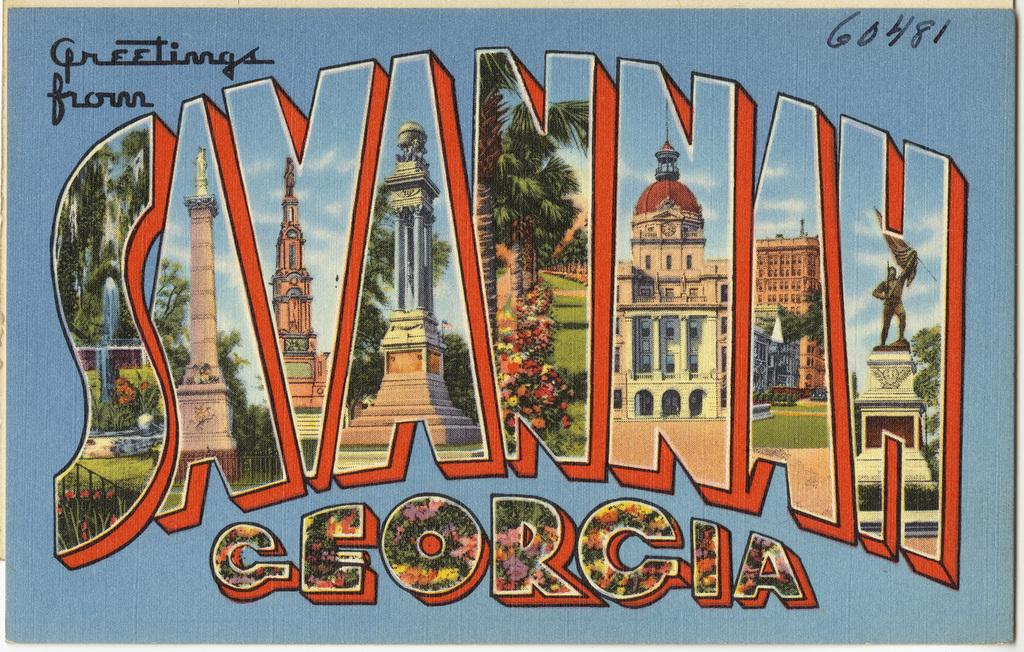Provide a one-sentence caption for the provided image. blue postcard that states greetings from savannah georgia. 